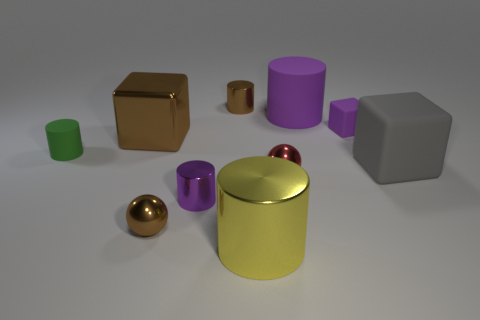There is a cylinder that is to the left of the tiny sphere in front of the red shiny thing; what is its size?
Provide a short and direct response. Small. Are the big gray thing and the small purple object in front of the gray cube made of the same material?
Your answer should be very brief. No. Is the number of small purple things in front of the large brown thing less than the number of metallic things that are behind the small red metal ball?
Keep it short and to the point. Yes. There is a ball that is the same material as the small red thing; what color is it?
Offer a very short reply. Brown. There is a tiny metallic cylinder that is in front of the brown cylinder; are there any tiny cylinders that are behind it?
Provide a short and direct response. Yes. What is the color of the rubber block that is the same size as the red metallic object?
Your answer should be compact. Purple. How many things are either small gray matte cylinders or large brown metallic blocks?
Ensure brevity in your answer.  1. There is a shiny sphere that is in front of the tiny metallic sphere that is to the right of the brown metallic object that is behind the small purple rubber object; what is its size?
Provide a succinct answer. Small. How many cylinders are the same color as the small block?
Offer a terse response. 2. How many big brown blocks are made of the same material as the tiny red ball?
Your answer should be compact. 1. 